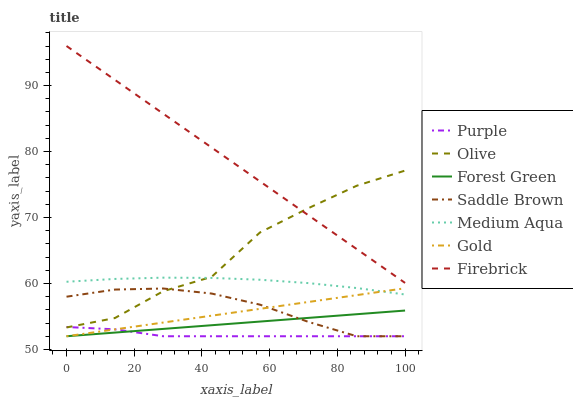Does Purple have the minimum area under the curve?
Answer yes or no. Yes. Does Firebrick have the maximum area under the curve?
Answer yes or no. Yes. Does Firebrick have the minimum area under the curve?
Answer yes or no. No. Does Purple have the maximum area under the curve?
Answer yes or no. No. Is Forest Green the smoothest?
Answer yes or no. Yes. Is Olive the roughest?
Answer yes or no. Yes. Is Purple the smoothest?
Answer yes or no. No. Is Purple the roughest?
Answer yes or no. No. Does Gold have the lowest value?
Answer yes or no. Yes. Does Firebrick have the lowest value?
Answer yes or no. No. Does Firebrick have the highest value?
Answer yes or no. Yes. Does Purple have the highest value?
Answer yes or no. No. Is Gold less than Firebrick?
Answer yes or no. Yes. Is Olive greater than Gold?
Answer yes or no. Yes. Does Medium Aqua intersect Olive?
Answer yes or no. Yes. Is Medium Aqua less than Olive?
Answer yes or no. No. Is Medium Aqua greater than Olive?
Answer yes or no. No. Does Gold intersect Firebrick?
Answer yes or no. No. 